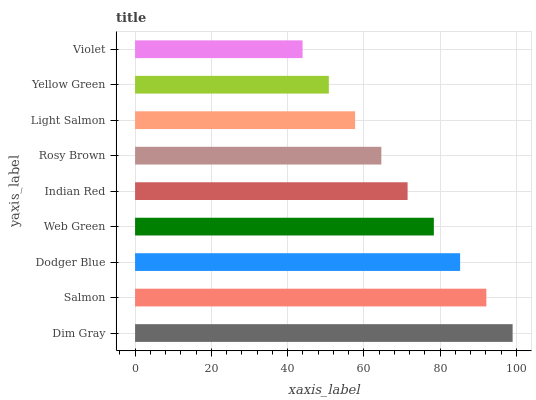Is Violet the minimum?
Answer yes or no. Yes. Is Dim Gray the maximum?
Answer yes or no. Yes. Is Salmon the minimum?
Answer yes or no. No. Is Salmon the maximum?
Answer yes or no. No. Is Dim Gray greater than Salmon?
Answer yes or no. Yes. Is Salmon less than Dim Gray?
Answer yes or no. Yes. Is Salmon greater than Dim Gray?
Answer yes or no. No. Is Dim Gray less than Salmon?
Answer yes or no. No. Is Indian Red the high median?
Answer yes or no. Yes. Is Indian Red the low median?
Answer yes or no. Yes. Is Dodger Blue the high median?
Answer yes or no. No. Is Light Salmon the low median?
Answer yes or no. No. 